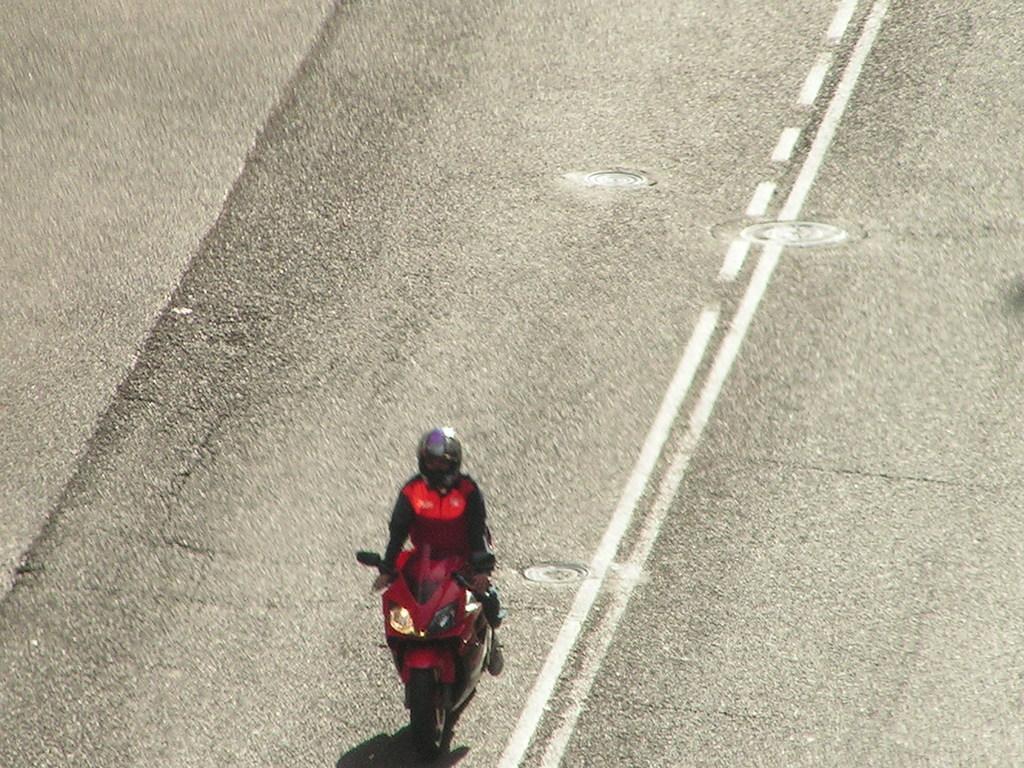Describe this image in one or two sentences. The person wearing red jacket is riding a red bike on the road and there are white lines on the road. 